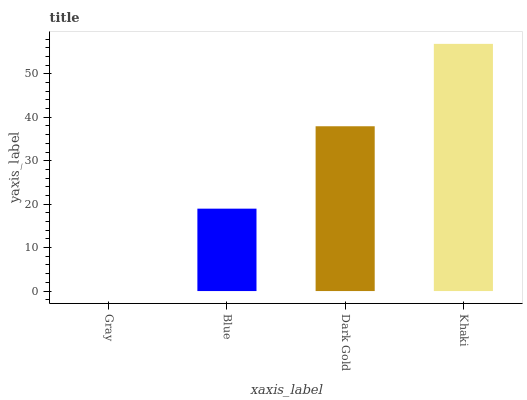Is Gray the minimum?
Answer yes or no. Yes. Is Khaki the maximum?
Answer yes or no. Yes. Is Blue the minimum?
Answer yes or no. No. Is Blue the maximum?
Answer yes or no. No. Is Blue greater than Gray?
Answer yes or no. Yes. Is Gray less than Blue?
Answer yes or no. Yes. Is Gray greater than Blue?
Answer yes or no. No. Is Blue less than Gray?
Answer yes or no. No. Is Dark Gold the high median?
Answer yes or no. Yes. Is Blue the low median?
Answer yes or no. Yes. Is Gray the high median?
Answer yes or no. No. Is Khaki the low median?
Answer yes or no. No. 